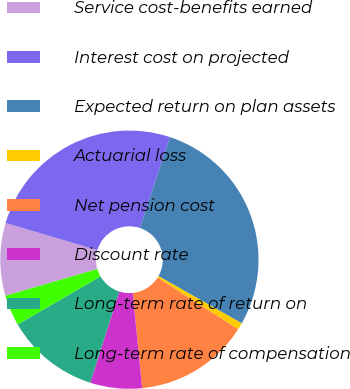Convert chart. <chart><loc_0><loc_0><loc_500><loc_500><pie_chart><fcel>Service cost-benefits earned<fcel>Interest cost on projected<fcel>Expected return on plan assets<fcel>Actuarial loss<fcel>Net pension cost<fcel>Discount rate<fcel>Long-term rate of return on<fcel>Long-term rate of compensation<nl><fcel>9.1%<fcel>25.49%<fcel>28.12%<fcel>0.86%<fcel>14.36%<fcel>6.48%<fcel>11.73%<fcel>3.85%<nl></chart> 